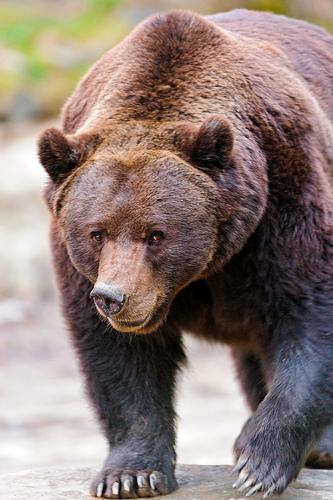Question: what is this?
Choices:
A. Car.
B. Baby.
C. Kite.
D. Bear.
Answer with the letter. Answer: D Question: how is the photo?
Choices:
A. Clear.
B. Black and white.
C. Antique.
D. A selfie.
Answer with the letter. Answer: A Question: who is present?
Choices:
A. The students.
B. The team.
C. The family.
D. No one.
Answer with the letter. Answer: D Question: what is on the ground?
Choices:
A. Grass.
B. The birds.
C. Stone.
D. Bread crumbs.
Answer with the letter. Answer: C Question: where is this scene?
Choices:
A. The zoo.
B. The park.
C. The aquarium.
D. The fair.
Answer with the letter. Answer: A 